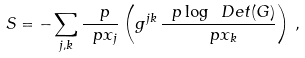Convert formula to latex. <formula><loc_0><loc_0><loc_500><loc_500>S = - \sum _ { j , k } \frac { \ p } { \ p x _ { j } } \left ( g ^ { j k } \, \frac { \ p \log \ D e t ( G ) } { \ p x _ { k } } \right ) \, ,</formula> 